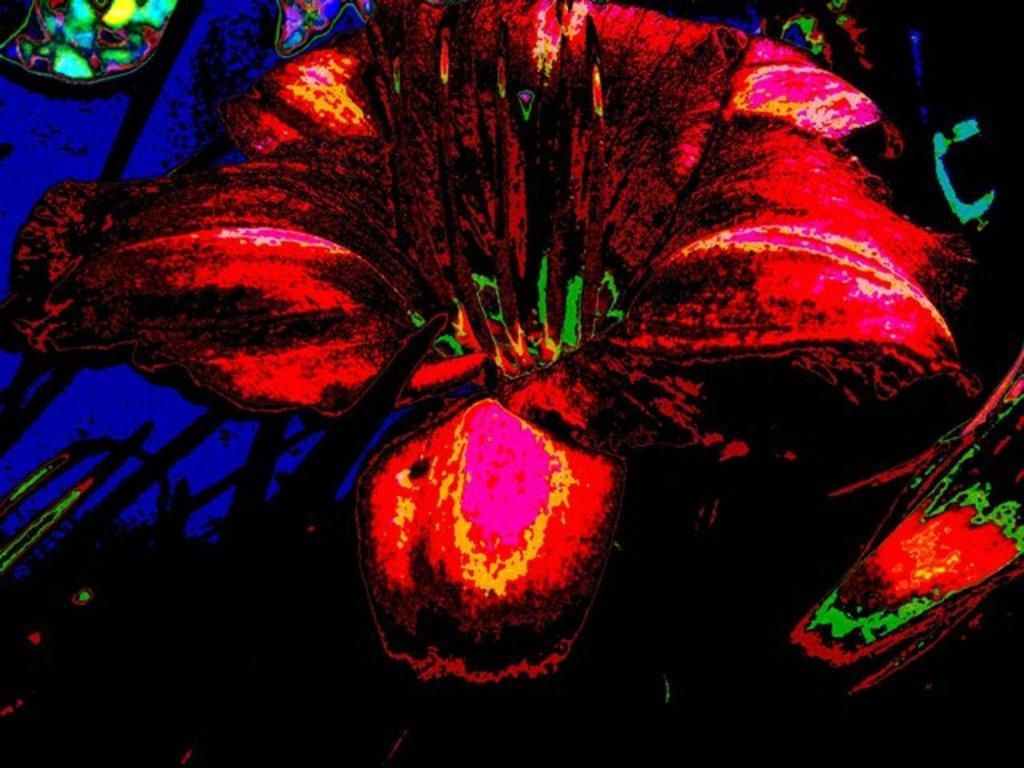Please provide a concise description of this image. In this image I can see a colorful design flower painting, in the background I can see black and blue color. 